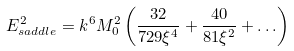Convert formula to latex. <formula><loc_0><loc_0><loc_500><loc_500>E _ { s a d d l e } ^ { 2 } = k ^ { 6 } M _ { 0 } ^ { 2 } \left ( { { \frac { 3 2 } { { 7 2 9 \xi ^ { 4 } } } } + { \frac { 4 0 } { { 8 1 \xi ^ { 2 } } } } + \dots } \right )</formula> 